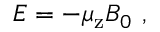<formula> <loc_0><loc_0><loc_500><loc_500>E = - \mu _ { z } B _ { 0 } \ ,</formula> 